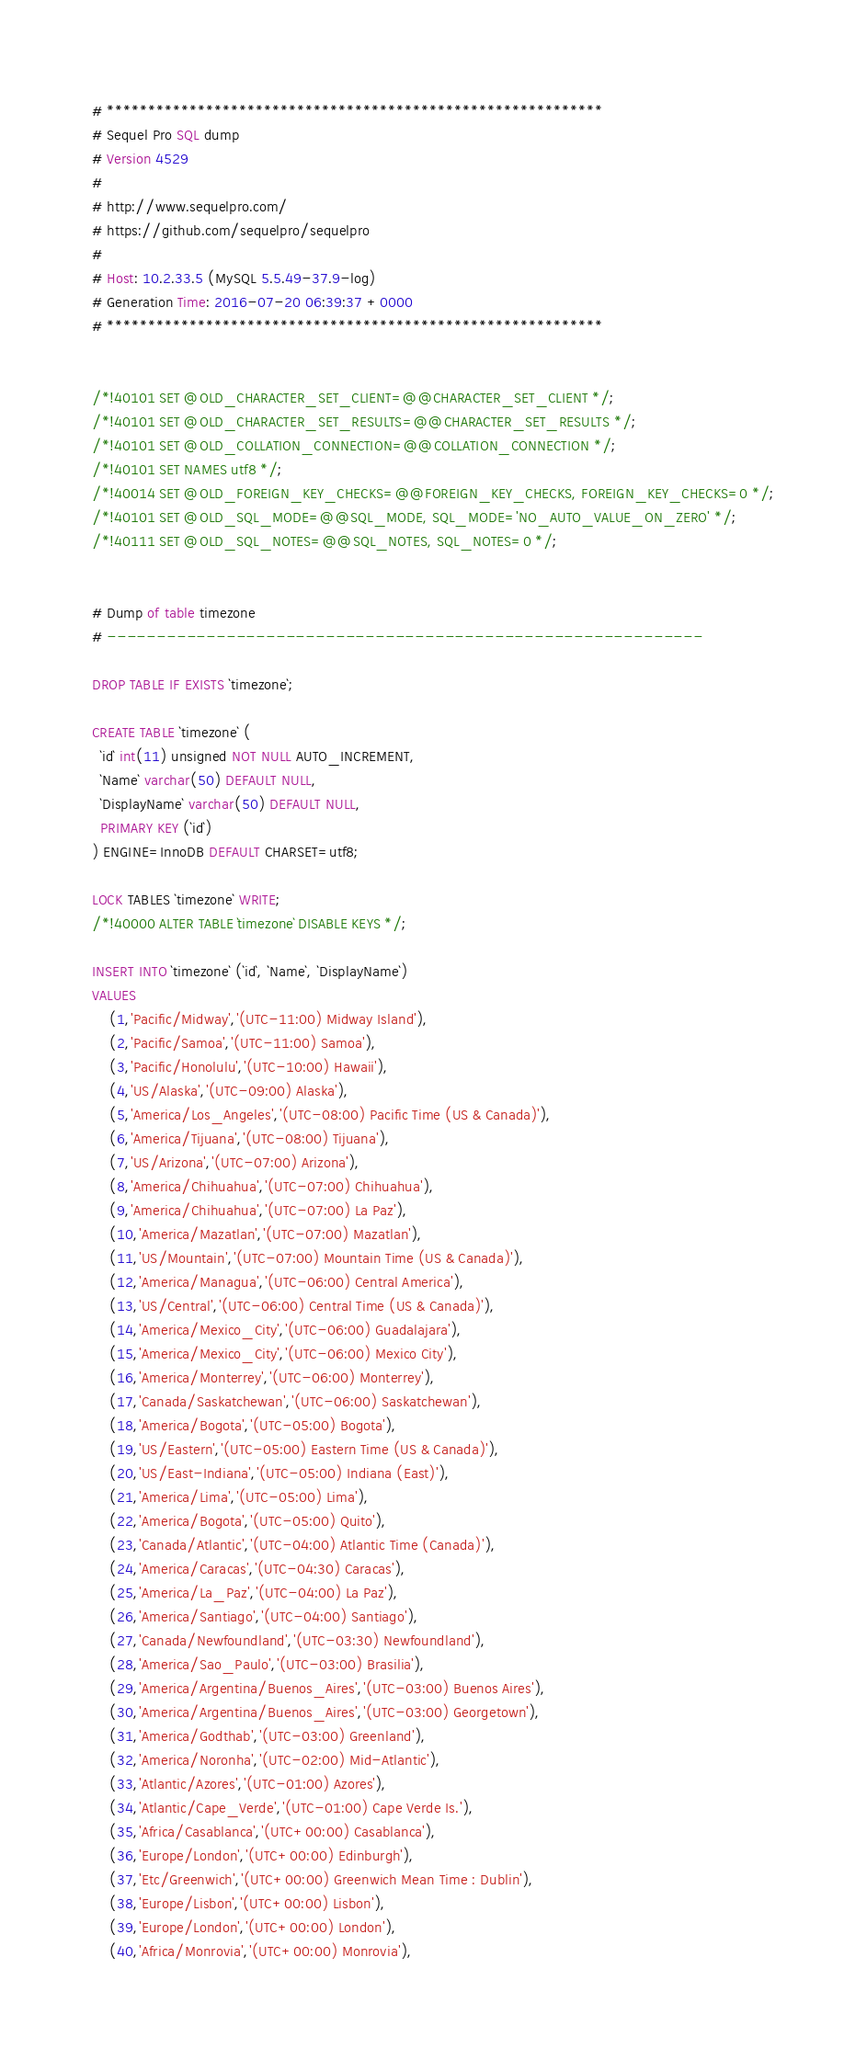Convert code to text. <code><loc_0><loc_0><loc_500><loc_500><_SQL_># ************************************************************
# Sequel Pro SQL dump
# Version 4529
#
# http://www.sequelpro.com/
# https://github.com/sequelpro/sequelpro
#
# Host: 10.2.33.5 (MySQL 5.5.49-37.9-log)
# Generation Time: 2016-07-20 06:39:37 +0000
# ************************************************************


/*!40101 SET @OLD_CHARACTER_SET_CLIENT=@@CHARACTER_SET_CLIENT */;
/*!40101 SET @OLD_CHARACTER_SET_RESULTS=@@CHARACTER_SET_RESULTS */;
/*!40101 SET @OLD_COLLATION_CONNECTION=@@COLLATION_CONNECTION */;
/*!40101 SET NAMES utf8 */;
/*!40014 SET @OLD_FOREIGN_KEY_CHECKS=@@FOREIGN_KEY_CHECKS, FOREIGN_KEY_CHECKS=0 */;
/*!40101 SET @OLD_SQL_MODE=@@SQL_MODE, SQL_MODE='NO_AUTO_VALUE_ON_ZERO' */;
/*!40111 SET @OLD_SQL_NOTES=@@SQL_NOTES, SQL_NOTES=0 */;


# Dump of table timezone
# ------------------------------------------------------------

DROP TABLE IF EXISTS `timezone`;

CREATE TABLE `timezone` (
  `id` int(11) unsigned NOT NULL AUTO_INCREMENT,
  `Name` varchar(50) DEFAULT NULL,
  `DisplayName` varchar(50) DEFAULT NULL,
  PRIMARY KEY (`id`)
) ENGINE=InnoDB DEFAULT CHARSET=utf8;

LOCK TABLES `timezone` WRITE;
/*!40000 ALTER TABLE `timezone` DISABLE KEYS */;

INSERT INTO `timezone` (`id`, `Name`, `DisplayName`)
VALUES
	(1,'Pacific/Midway','(UTC-11:00) Midway Island'),
	(2,'Pacific/Samoa','(UTC-11:00) Samoa'),
	(3,'Pacific/Honolulu','(UTC-10:00) Hawaii'),
	(4,'US/Alaska','(UTC-09:00) Alaska'),
	(5,'America/Los_Angeles','(UTC-08:00) Pacific Time (US & Canada)'),
	(6,'America/Tijuana','(UTC-08:00) Tijuana'),
	(7,'US/Arizona','(UTC-07:00) Arizona'),
	(8,'America/Chihuahua','(UTC-07:00) Chihuahua'),
	(9,'America/Chihuahua','(UTC-07:00) La Paz'),
	(10,'America/Mazatlan','(UTC-07:00) Mazatlan'),
	(11,'US/Mountain','(UTC-07:00) Mountain Time (US & Canada)'),
	(12,'America/Managua','(UTC-06:00) Central America'),
	(13,'US/Central','(UTC-06:00) Central Time (US & Canada)'),
	(14,'America/Mexico_City','(UTC-06:00) Guadalajara'),
	(15,'America/Mexico_City','(UTC-06:00) Mexico City'),
	(16,'America/Monterrey','(UTC-06:00) Monterrey'),
	(17,'Canada/Saskatchewan','(UTC-06:00) Saskatchewan'),
	(18,'America/Bogota','(UTC-05:00) Bogota'),
	(19,'US/Eastern','(UTC-05:00) Eastern Time (US & Canada)'),
	(20,'US/East-Indiana','(UTC-05:00) Indiana (East)'),
	(21,'America/Lima','(UTC-05:00) Lima'),
	(22,'America/Bogota','(UTC-05:00) Quito'),
	(23,'Canada/Atlantic','(UTC-04:00) Atlantic Time (Canada)'),
	(24,'America/Caracas','(UTC-04:30) Caracas'),
	(25,'America/La_Paz','(UTC-04:00) La Paz'),
	(26,'America/Santiago','(UTC-04:00) Santiago'),
	(27,'Canada/Newfoundland','(UTC-03:30) Newfoundland'),
	(28,'America/Sao_Paulo','(UTC-03:00) Brasilia'),
	(29,'America/Argentina/Buenos_Aires','(UTC-03:00) Buenos Aires'),
	(30,'America/Argentina/Buenos_Aires','(UTC-03:00) Georgetown'),
	(31,'America/Godthab','(UTC-03:00) Greenland'),
	(32,'America/Noronha','(UTC-02:00) Mid-Atlantic'),
	(33,'Atlantic/Azores','(UTC-01:00) Azores'),
	(34,'Atlantic/Cape_Verde','(UTC-01:00) Cape Verde Is.'),
	(35,'Africa/Casablanca','(UTC+00:00) Casablanca'),
	(36,'Europe/London','(UTC+00:00) Edinburgh'),
	(37,'Etc/Greenwich','(UTC+00:00) Greenwich Mean Time : Dublin'),
	(38,'Europe/Lisbon','(UTC+00:00) Lisbon'),
	(39,'Europe/London','(UTC+00:00) London'),
	(40,'Africa/Monrovia','(UTC+00:00) Monrovia'),</code> 